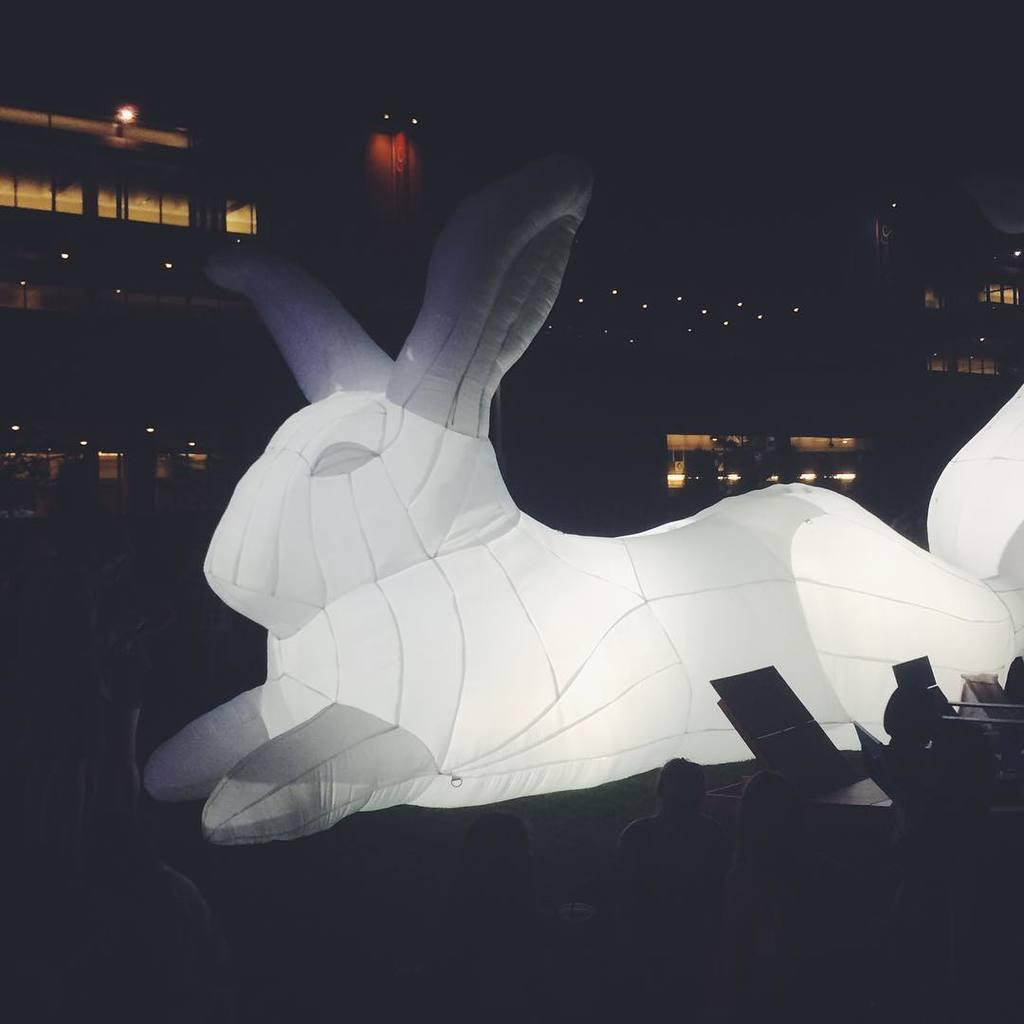What type of object is in the foreground of the image? There is an inflatable animal in the image. What can be seen in the background of the image? There is a building behind the inflatable animal. What type of news can be heard coming from the bushes in the image? There are no bushes or news present in the image; it features an inflatable animal and a building in the background. 